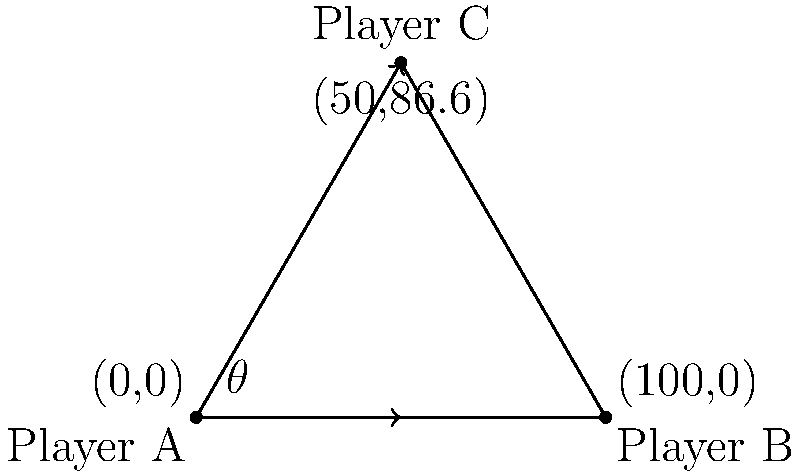In a rugby match, Player A is about to pass the ball to Player C, who is running towards the try line. Given that the optimal passing angle $\theta$ maximizes the component of the pass velocity in Player C's direction of motion, what is this optimal angle? Assume Player C is running perpendicular to the line between Players A and B. To determine the optimal passing angle, we need to follow these steps:

1) The scenario forms a right-angled triangle, with Player C at the right angle.

2) The pass from A to C forms the hypotenuse of this triangle.

3) The component of the pass velocity in Player C's direction is represented by the vertical side of the triangle.

4) To maximize this component, we need to maximize $v \sin(\theta)$, where $v$ is the pass velocity.

5) The maximum value of $\sin(\theta)$ occurs when $\theta = 90°$.

6) However, this would mean passing straight up, which isn't practical in rugby.

7) The next best angle is 45°, which provides the optimal balance between forward distance and lateral distance.

8) At 45°, both $\sin(\theta)$ and $\cos(\theta)$ equal $\frac{1}{\sqrt{2}}$, providing equal components in both directions.

9) This angle allows for a pass that travels significantly forward while also moving laterally towards the receiver.

Therefore, the optimal passing angle that maximizes the component of the pass velocity in Player C's direction, while still moving the ball forward, is 45°.
Answer: 45° 